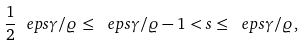<formula> <loc_0><loc_0><loc_500><loc_500>\frac { 1 } { 2 } \ e p s \gamma / \varrho \leq \ e p s \gamma / \varrho - 1 < s \leq \ e p s \gamma / \varrho ,</formula> 